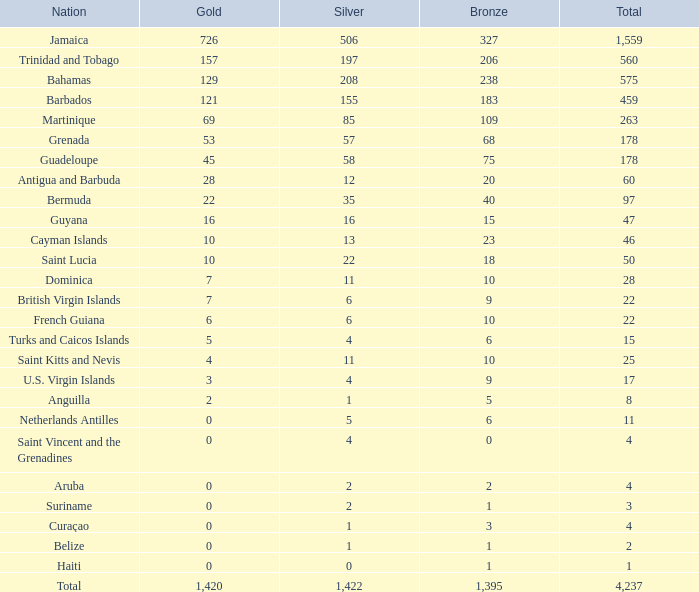Which country possesses a bronze smaller than 10 and a silver of 5? Netherlands Antilles. 